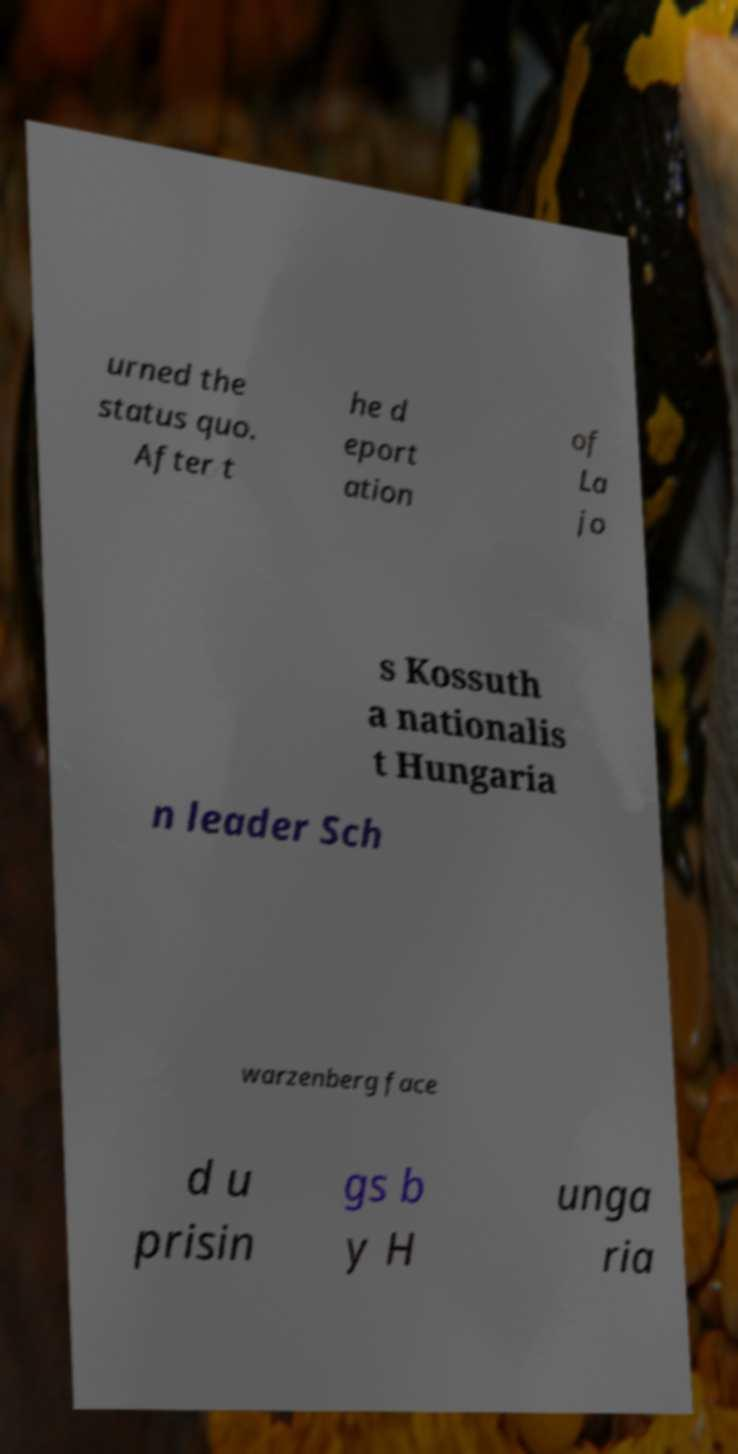What messages or text are displayed in this image? I need them in a readable, typed format. urned the status quo. After t he d eport ation of La jo s Kossuth a nationalis t Hungaria n leader Sch warzenberg face d u prisin gs b y H unga ria 